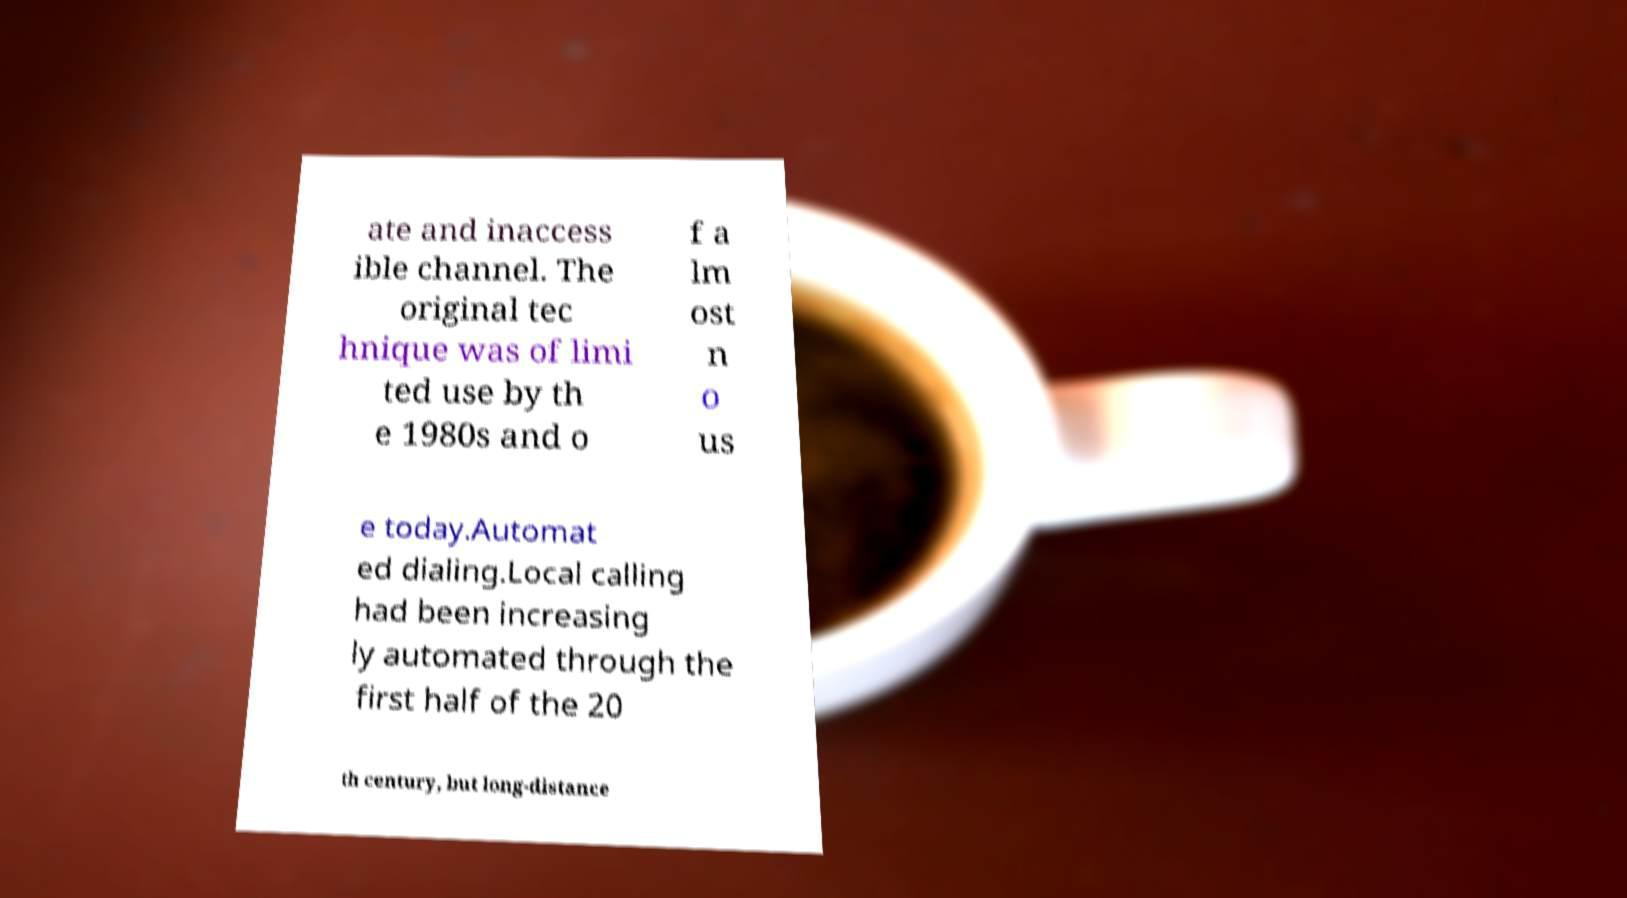For documentation purposes, I need the text within this image transcribed. Could you provide that? ate and inaccess ible channel. The original tec hnique was of limi ted use by th e 1980s and o f a lm ost n o us e today.Automat ed dialing.Local calling had been increasing ly automated through the first half of the 20 th century, but long-distance 